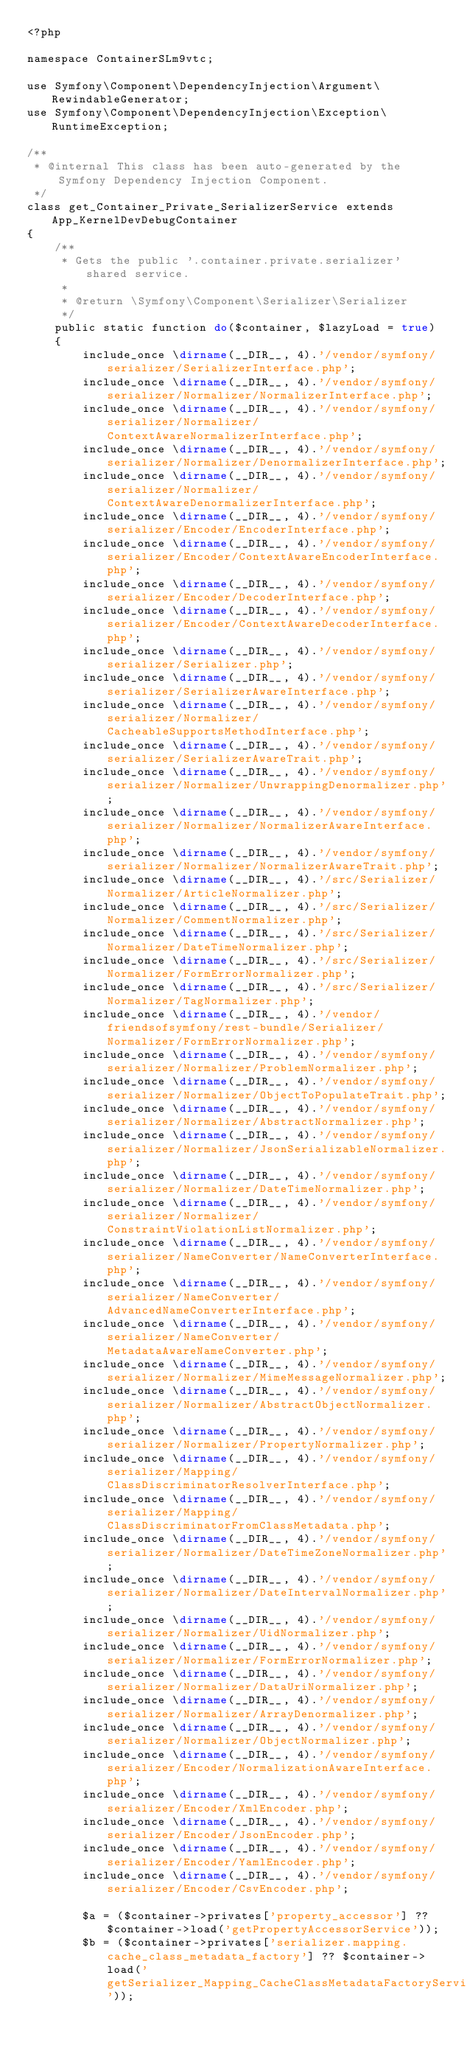<code> <loc_0><loc_0><loc_500><loc_500><_PHP_><?php

namespace ContainerSLm9vtc;

use Symfony\Component\DependencyInjection\Argument\RewindableGenerator;
use Symfony\Component\DependencyInjection\Exception\RuntimeException;

/**
 * @internal This class has been auto-generated by the Symfony Dependency Injection Component.
 */
class get_Container_Private_SerializerService extends App_KernelDevDebugContainer
{
    /**
     * Gets the public '.container.private.serializer' shared service.
     *
     * @return \Symfony\Component\Serializer\Serializer
     */
    public static function do($container, $lazyLoad = true)
    {
        include_once \dirname(__DIR__, 4).'/vendor/symfony/serializer/SerializerInterface.php';
        include_once \dirname(__DIR__, 4).'/vendor/symfony/serializer/Normalizer/NormalizerInterface.php';
        include_once \dirname(__DIR__, 4).'/vendor/symfony/serializer/Normalizer/ContextAwareNormalizerInterface.php';
        include_once \dirname(__DIR__, 4).'/vendor/symfony/serializer/Normalizer/DenormalizerInterface.php';
        include_once \dirname(__DIR__, 4).'/vendor/symfony/serializer/Normalizer/ContextAwareDenormalizerInterface.php';
        include_once \dirname(__DIR__, 4).'/vendor/symfony/serializer/Encoder/EncoderInterface.php';
        include_once \dirname(__DIR__, 4).'/vendor/symfony/serializer/Encoder/ContextAwareEncoderInterface.php';
        include_once \dirname(__DIR__, 4).'/vendor/symfony/serializer/Encoder/DecoderInterface.php';
        include_once \dirname(__DIR__, 4).'/vendor/symfony/serializer/Encoder/ContextAwareDecoderInterface.php';
        include_once \dirname(__DIR__, 4).'/vendor/symfony/serializer/Serializer.php';
        include_once \dirname(__DIR__, 4).'/vendor/symfony/serializer/SerializerAwareInterface.php';
        include_once \dirname(__DIR__, 4).'/vendor/symfony/serializer/Normalizer/CacheableSupportsMethodInterface.php';
        include_once \dirname(__DIR__, 4).'/vendor/symfony/serializer/SerializerAwareTrait.php';
        include_once \dirname(__DIR__, 4).'/vendor/symfony/serializer/Normalizer/UnwrappingDenormalizer.php';
        include_once \dirname(__DIR__, 4).'/vendor/symfony/serializer/Normalizer/NormalizerAwareInterface.php';
        include_once \dirname(__DIR__, 4).'/vendor/symfony/serializer/Normalizer/NormalizerAwareTrait.php';
        include_once \dirname(__DIR__, 4).'/src/Serializer/Normalizer/ArticleNormalizer.php';
        include_once \dirname(__DIR__, 4).'/src/Serializer/Normalizer/CommentNormalizer.php';
        include_once \dirname(__DIR__, 4).'/src/Serializer/Normalizer/DateTimeNormalizer.php';
        include_once \dirname(__DIR__, 4).'/src/Serializer/Normalizer/FormErrorNormalizer.php';
        include_once \dirname(__DIR__, 4).'/src/Serializer/Normalizer/TagNormalizer.php';
        include_once \dirname(__DIR__, 4).'/vendor/friendsofsymfony/rest-bundle/Serializer/Normalizer/FormErrorNormalizer.php';
        include_once \dirname(__DIR__, 4).'/vendor/symfony/serializer/Normalizer/ProblemNormalizer.php';
        include_once \dirname(__DIR__, 4).'/vendor/symfony/serializer/Normalizer/ObjectToPopulateTrait.php';
        include_once \dirname(__DIR__, 4).'/vendor/symfony/serializer/Normalizer/AbstractNormalizer.php';
        include_once \dirname(__DIR__, 4).'/vendor/symfony/serializer/Normalizer/JsonSerializableNormalizer.php';
        include_once \dirname(__DIR__, 4).'/vendor/symfony/serializer/Normalizer/DateTimeNormalizer.php';
        include_once \dirname(__DIR__, 4).'/vendor/symfony/serializer/Normalizer/ConstraintViolationListNormalizer.php';
        include_once \dirname(__DIR__, 4).'/vendor/symfony/serializer/NameConverter/NameConverterInterface.php';
        include_once \dirname(__DIR__, 4).'/vendor/symfony/serializer/NameConverter/AdvancedNameConverterInterface.php';
        include_once \dirname(__DIR__, 4).'/vendor/symfony/serializer/NameConverter/MetadataAwareNameConverter.php';
        include_once \dirname(__DIR__, 4).'/vendor/symfony/serializer/Normalizer/MimeMessageNormalizer.php';
        include_once \dirname(__DIR__, 4).'/vendor/symfony/serializer/Normalizer/AbstractObjectNormalizer.php';
        include_once \dirname(__DIR__, 4).'/vendor/symfony/serializer/Normalizer/PropertyNormalizer.php';
        include_once \dirname(__DIR__, 4).'/vendor/symfony/serializer/Mapping/ClassDiscriminatorResolverInterface.php';
        include_once \dirname(__DIR__, 4).'/vendor/symfony/serializer/Mapping/ClassDiscriminatorFromClassMetadata.php';
        include_once \dirname(__DIR__, 4).'/vendor/symfony/serializer/Normalizer/DateTimeZoneNormalizer.php';
        include_once \dirname(__DIR__, 4).'/vendor/symfony/serializer/Normalizer/DateIntervalNormalizer.php';
        include_once \dirname(__DIR__, 4).'/vendor/symfony/serializer/Normalizer/UidNormalizer.php';
        include_once \dirname(__DIR__, 4).'/vendor/symfony/serializer/Normalizer/FormErrorNormalizer.php';
        include_once \dirname(__DIR__, 4).'/vendor/symfony/serializer/Normalizer/DataUriNormalizer.php';
        include_once \dirname(__DIR__, 4).'/vendor/symfony/serializer/Normalizer/ArrayDenormalizer.php';
        include_once \dirname(__DIR__, 4).'/vendor/symfony/serializer/Normalizer/ObjectNormalizer.php';
        include_once \dirname(__DIR__, 4).'/vendor/symfony/serializer/Encoder/NormalizationAwareInterface.php';
        include_once \dirname(__DIR__, 4).'/vendor/symfony/serializer/Encoder/XmlEncoder.php';
        include_once \dirname(__DIR__, 4).'/vendor/symfony/serializer/Encoder/JsonEncoder.php';
        include_once \dirname(__DIR__, 4).'/vendor/symfony/serializer/Encoder/YamlEncoder.php';
        include_once \dirname(__DIR__, 4).'/vendor/symfony/serializer/Encoder/CsvEncoder.php';

        $a = ($container->privates['property_accessor'] ?? $container->load('getPropertyAccessorService'));
        $b = ($container->privates['serializer.mapping.cache_class_metadata_factory'] ?? $container->load('getSerializer_Mapping_CacheClassMetadataFactoryService'));
</code> 